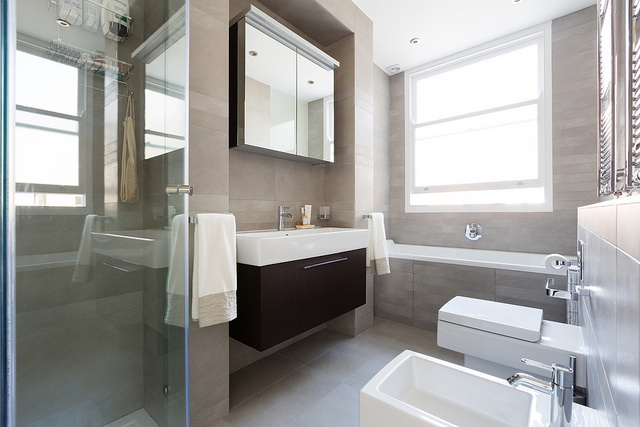Describe the objects in this image and their specific colors. I can see sink in gray, lightgray, and darkgray tones, toilet in gray, darkgray, and lightgray tones, sink in gray and darkgray tones, and sink in gray, lightgray, and darkgray tones in this image. 